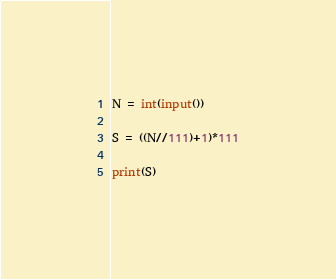Convert code to text. <code><loc_0><loc_0><loc_500><loc_500><_Python_>N = int(input())

S = ((N//111)+1)*111

print(S)</code> 